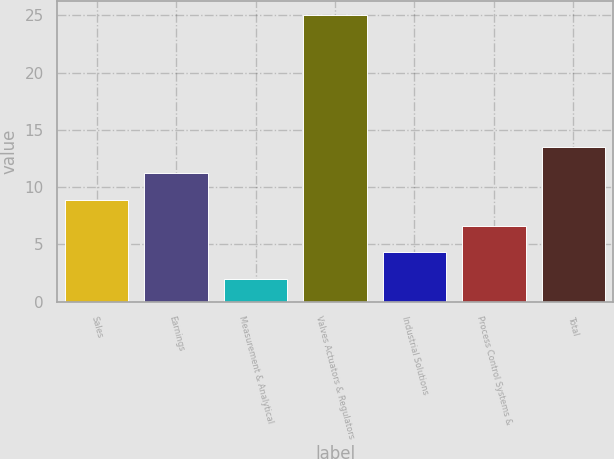<chart> <loc_0><loc_0><loc_500><loc_500><bar_chart><fcel>Sales<fcel>Earnings<fcel>Measurement & Analytical<fcel>Valves Actuators & Regulators<fcel>Industrial Solutions<fcel>Process Control Systems &<fcel>Total<nl><fcel>8.9<fcel>11.2<fcel>2<fcel>25<fcel>4.3<fcel>6.6<fcel>13.5<nl></chart> 